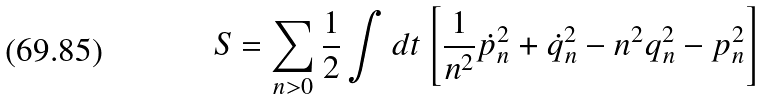<formula> <loc_0><loc_0><loc_500><loc_500>S = \sum _ { n > 0 } \frac { 1 } { 2 } \int d t \left [ \frac { 1 } { n ^ { 2 } } \dot { p } _ { n } ^ { 2 } + \dot { q } ^ { 2 } _ { n } - n ^ { 2 } q _ { n } ^ { 2 } - p _ { n } ^ { 2 } \right ]</formula> 